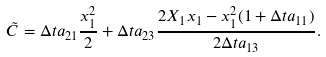Convert formula to latex. <formula><loc_0><loc_0><loc_500><loc_500>\tilde { C } = \Delta t a _ { 2 1 } \frac { x _ { 1 } ^ { 2 } } { 2 } + \Delta t a _ { 2 3 } \frac { 2 X _ { 1 } x _ { 1 } - x _ { 1 } ^ { 2 } ( 1 + \Delta t a _ { 1 1 } ) } { 2 \Delta t a _ { 1 3 } } .</formula> 